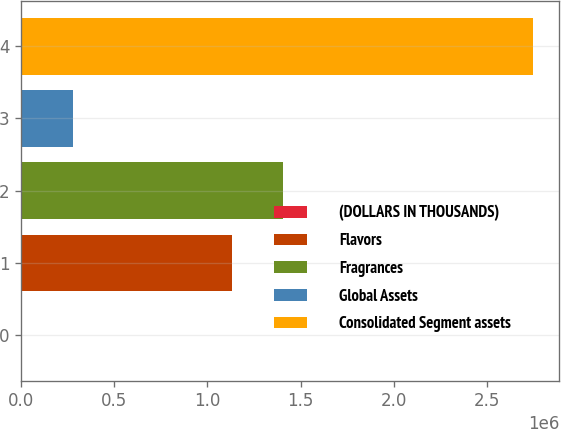Convert chart. <chart><loc_0><loc_0><loc_500><loc_500><bar_chart><fcel>(DOLLARS IN THOUSANDS)<fcel>Flavors<fcel>Fragrances<fcel>Global Assets<fcel>Consolidated Segment assets<nl><fcel>2008<fcel>1.13178e+06<fcel>1.40657e+06<fcel>276798<fcel>2.74991e+06<nl></chart> 